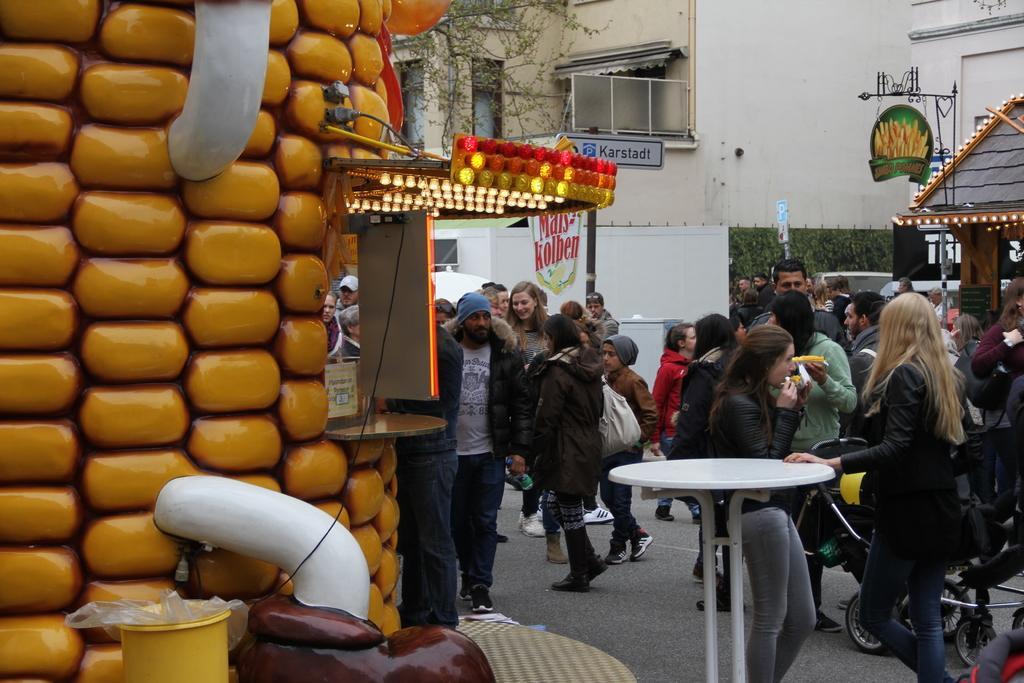What are the people in the image doing? The people in the image are standing on the road. What object can be seen in the image besides the people? There is a table in the image. What can be seen in the background of the image? There is a wall and plants in the background of the image. Can you describe the natural element visible in the image? There is a tree visible in the image. What type of stitch is being used to sew the songs together in the image? There are no songs or stitching present in the image; it features people standing on the road, a table, a wall, plants, and a tree. 